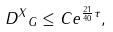<formula> <loc_0><loc_0><loc_500><loc_500>\| D ^ { X } \| _ { G } \leq C e ^ { \frac { 2 1 } { 4 0 } \tau } ,</formula> 